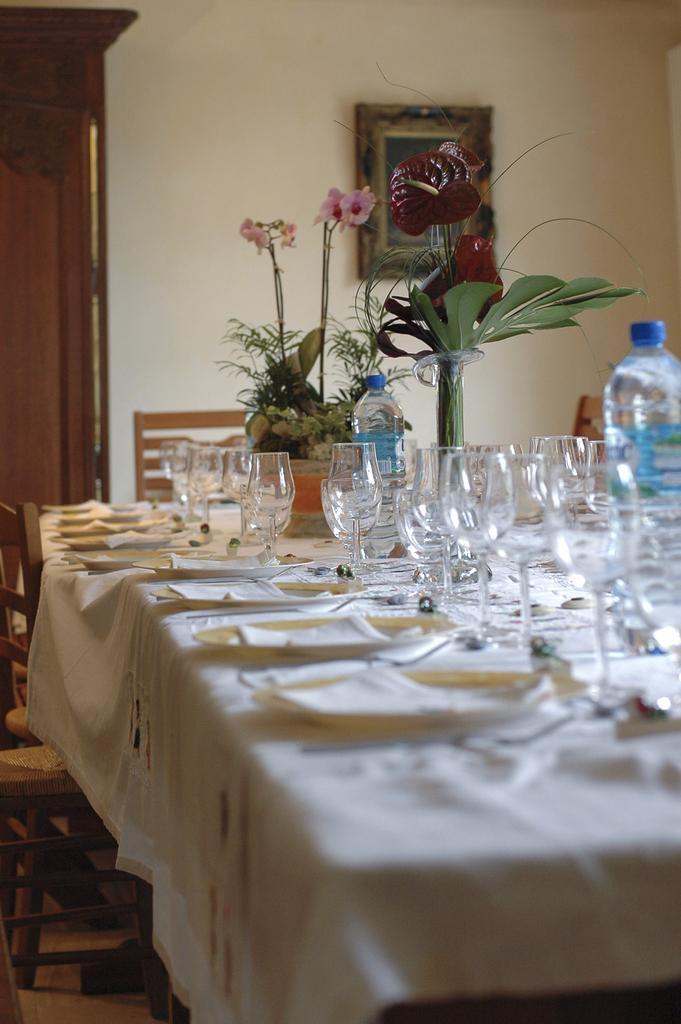Can you describe this image briefly? As we can see in the image there is a white color wall, a table. On table there are plates, white color cloth, glasses, bottle and a flask. 